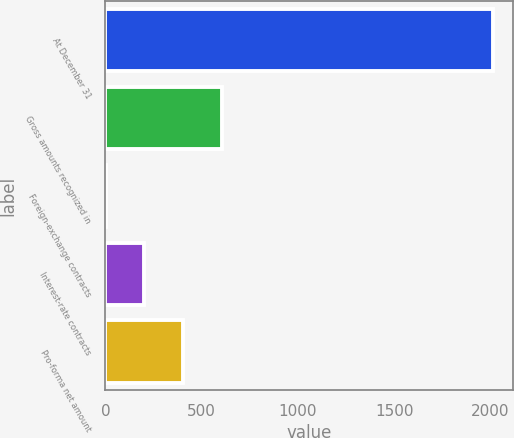Convert chart. <chart><loc_0><loc_0><loc_500><loc_500><bar_chart><fcel>At December 31<fcel>Gross amounts recognized in<fcel>Foreign-exchange contracts<fcel>Interest-rate contracts<fcel>Pro-forma net amount<nl><fcel>2015<fcel>604.78<fcel>0.4<fcel>201.86<fcel>403.32<nl></chart> 